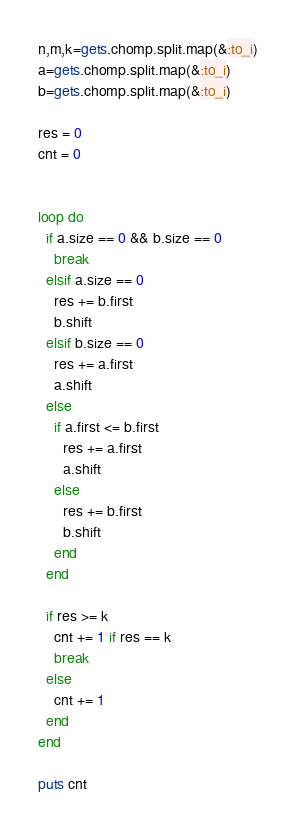<code> <loc_0><loc_0><loc_500><loc_500><_Ruby_>n,m,k=gets.chomp.split.map(&:to_i)
a=gets.chomp.split.map(&:to_i)
b=gets.chomp.split.map(&:to_i)

res = 0
cnt = 0


loop do
  if a.size == 0 && b.size == 0
    break
  elsif a.size == 0
    res += b.first
    b.shift
  elsif b.size == 0
    res += a.first
    a.shift
  else
    if a.first <= b.first
      res += a.first
      a.shift
    else
      res += b.first
      b.shift
    end
  end

  if res >= k
    cnt += 1 if res == k
    break
  else
    cnt += 1
  end
end

puts cnt</code> 